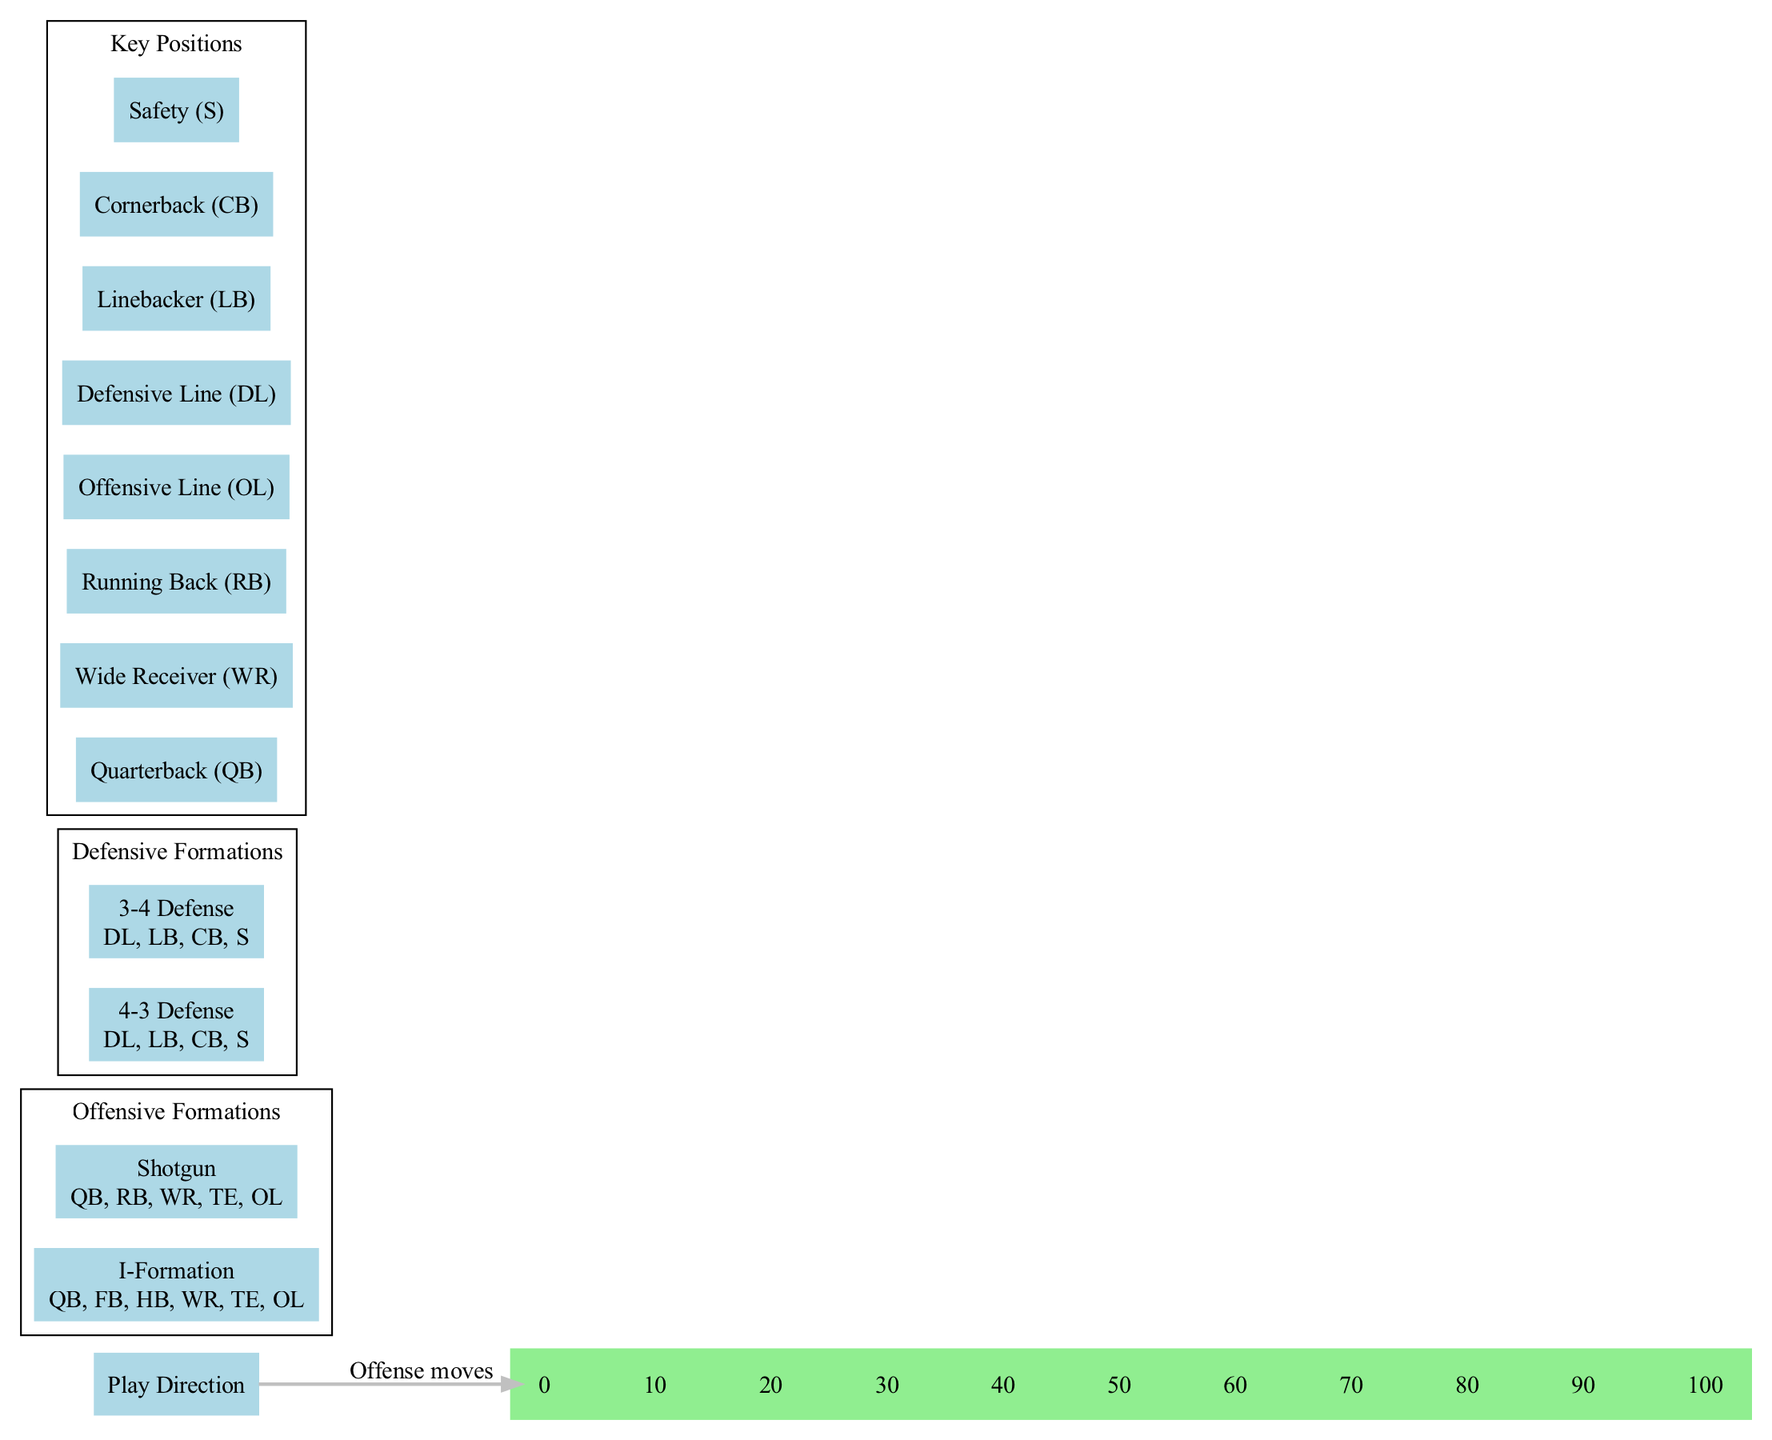What are the two offensive formations shown in the diagram? The diagram lists two offensive formations: I-Formation and Shotgun. These names can be found within the "Offensive Formations" section of the diagram.
Answer: I-Formation, Shotgun How many players are in the I-Formation? The I-Formation consists of six players: Quarterback (QB), Fullback (FB), Halfback (HB), Wide Receiver (WR), Tight End (TE), and Offensive Line (OL), which are all listed together in the formation's description in the diagram.
Answer: 6 What is the play direction indicated in the diagram? The diagram features an arrow pointing towards one side, indicating the direction in which the offense is moving. This arrow is labeled 'Offense moves', making it clear what the direction signifies.
Answer: Offense moves What positions are included in the 4-3 Defense? The 4-3 Defense includes Defensive Line (DL), Linebackers (LB), Cornerbacks (CB), and Safeties (S). These positions are detailed in the description of the 4-3 Defense formation within the diagram.
Answer: DL, LB, CB, S How many defensive formations are shown in the diagram? The diagram displays two defensive formations: 4-3 Defense and 3-4 Defense. This can be confirmed by counting the formations listed under "Defensive Formations."
Answer: 2 Which offensive formation has a Halfback? The I-Formation specifically includes a Halfback (HB) as one of its players, whereas the Shotgun formation does not include this position in its list. Since the I-Formation is the only one that includes a Halfback, the answer is derived from comparing both formations.
Answer: I-Formation What is the total number of key positions highlighted? There are eight key positions listed in the diagram: Quarterback (QB), Wide Receiver (WR), Running Back (RB), Offensive Line (OL), Defensive Line (DL), Linebacker (LB), Cornerback (CB), and Safety (S). This can be confirmed by counting the positions under "Key Positions."
Answer: 8 What indicates the relationship between play direction and yard lines? The diagram shows an edge labeled 'Offense moves' connecting the play direction node to the first yard line (yard_0). This indicates that the offense will move down the field towards scoring, visually representing the action on the football field.
Answer: Offense moves to yard_0 What is the shape of the football field depicted in the diagram? The shape of the football field in the diagram is described as a rectangle, which is characteristic of a standard football field layout. This attribute is explicitly mentioned in the diagram's description.
Answer: Rectangle 